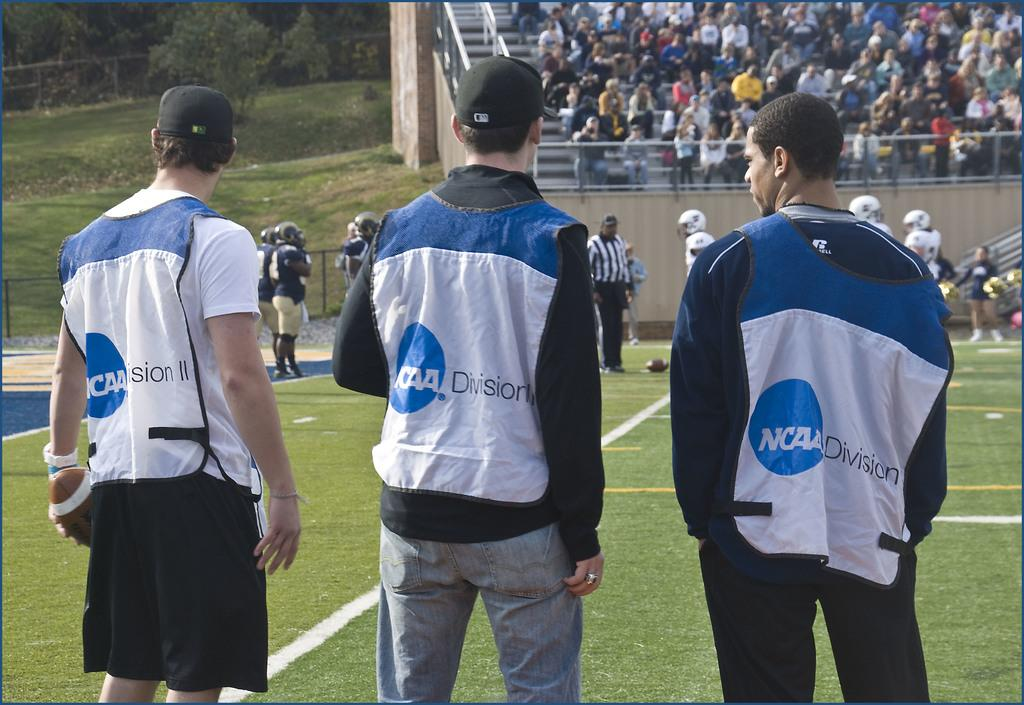<image>
Provide a brief description of the given image. Three men standing on the sidelines wearing NCAA Division vests. 